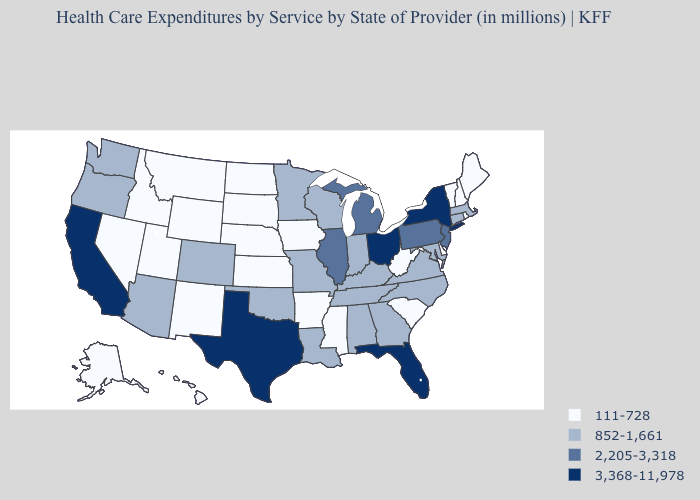What is the value of Georgia?
Answer briefly. 852-1,661. Among the states that border Nebraska , which have the highest value?
Write a very short answer. Colorado, Missouri. What is the value of Oklahoma?
Answer briefly. 852-1,661. What is the highest value in states that border Pennsylvania?
Give a very brief answer. 3,368-11,978. What is the value of South Carolina?
Concise answer only. 111-728. What is the value of New Hampshire?
Be succinct. 111-728. What is the lowest value in the USA?
Keep it brief. 111-728. What is the value of New Mexico?
Quick response, please. 111-728. Name the states that have a value in the range 2,205-3,318?
Give a very brief answer. Illinois, Michigan, New Jersey, Pennsylvania. What is the highest value in the USA?
Keep it brief. 3,368-11,978. Among the states that border Arizona , does California have the highest value?
Concise answer only. Yes. What is the highest value in the South ?
Write a very short answer. 3,368-11,978. Name the states that have a value in the range 111-728?
Write a very short answer. Alaska, Arkansas, Delaware, Hawaii, Idaho, Iowa, Kansas, Maine, Mississippi, Montana, Nebraska, Nevada, New Hampshire, New Mexico, North Dakota, Rhode Island, South Carolina, South Dakota, Utah, Vermont, West Virginia, Wyoming. Name the states that have a value in the range 852-1,661?
Short answer required. Alabama, Arizona, Colorado, Connecticut, Georgia, Indiana, Kentucky, Louisiana, Maryland, Massachusetts, Minnesota, Missouri, North Carolina, Oklahoma, Oregon, Tennessee, Virginia, Washington, Wisconsin. What is the lowest value in the USA?
Give a very brief answer. 111-728. 